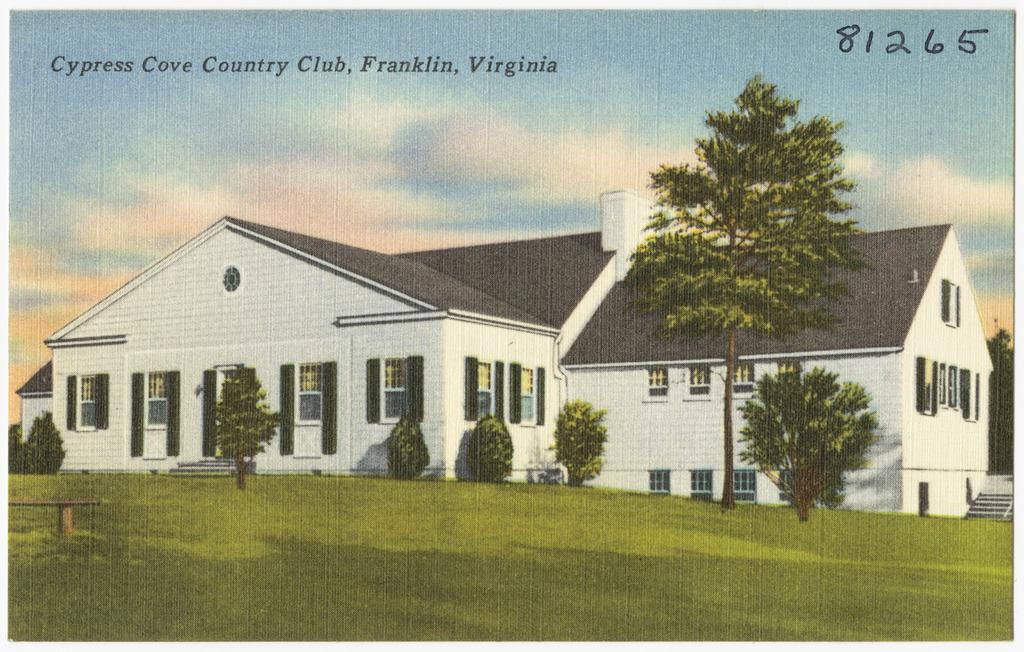What type of vegetation can be seen in the image? There is grass in the image. What type of seating is present in the image? There is a bench in the image. What other natural elements can be seen in the image? There are trees in the image. What type of structure is visible in the image? There is a house in the image. What is visible in the background of the image? The sky is visible in the background of the image. What additional information is present at the top of the image? There is text and a number at the top of the image. What type of bedroom can be seen in the image? There is no bedroom present in the image. What type of credit is being offered in the image? There is no credit being offered in the image. 